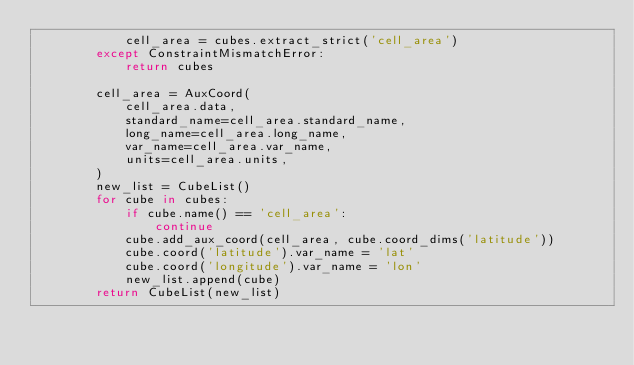Convert code to text. <code><loc_0><loc_0><loc_500><loc_500><_Python_>            cell_area = cubes.extract_strict('cell_area')
        except ConstraintMismatchError:
            return cubes

        cell_area = AuxCoord(
            cell_area.data,
            standard_name=cell_area.standard_name,
            long_name=cell_area.long_name,
            var_name=cell_area.var_name,
            units=cell_area.units,
        )
        new_list = CubeList()
        for cube in cubes:
            if cube.name() == 'cell_area':
                continue
            cube.add_aux_coord(cell_area, cube.coord_dims('latitude'))
            cube.coord('latitude').var_name = 'lat'
            cube.coord('longitude').var_name = 'lon'
            new_list.append(cube)
        return CubeList(new_list)
</code> 